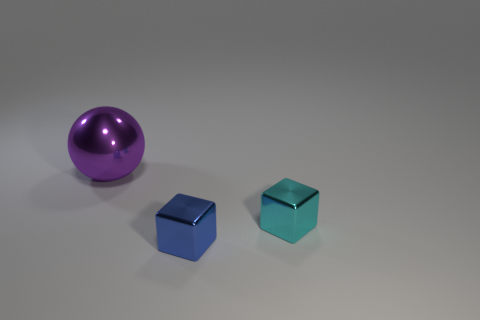Is the number of tiny cyan blocks that are in front of the cyan block the same as the number of shiny cubes that are in front of the large metallic ball? no 